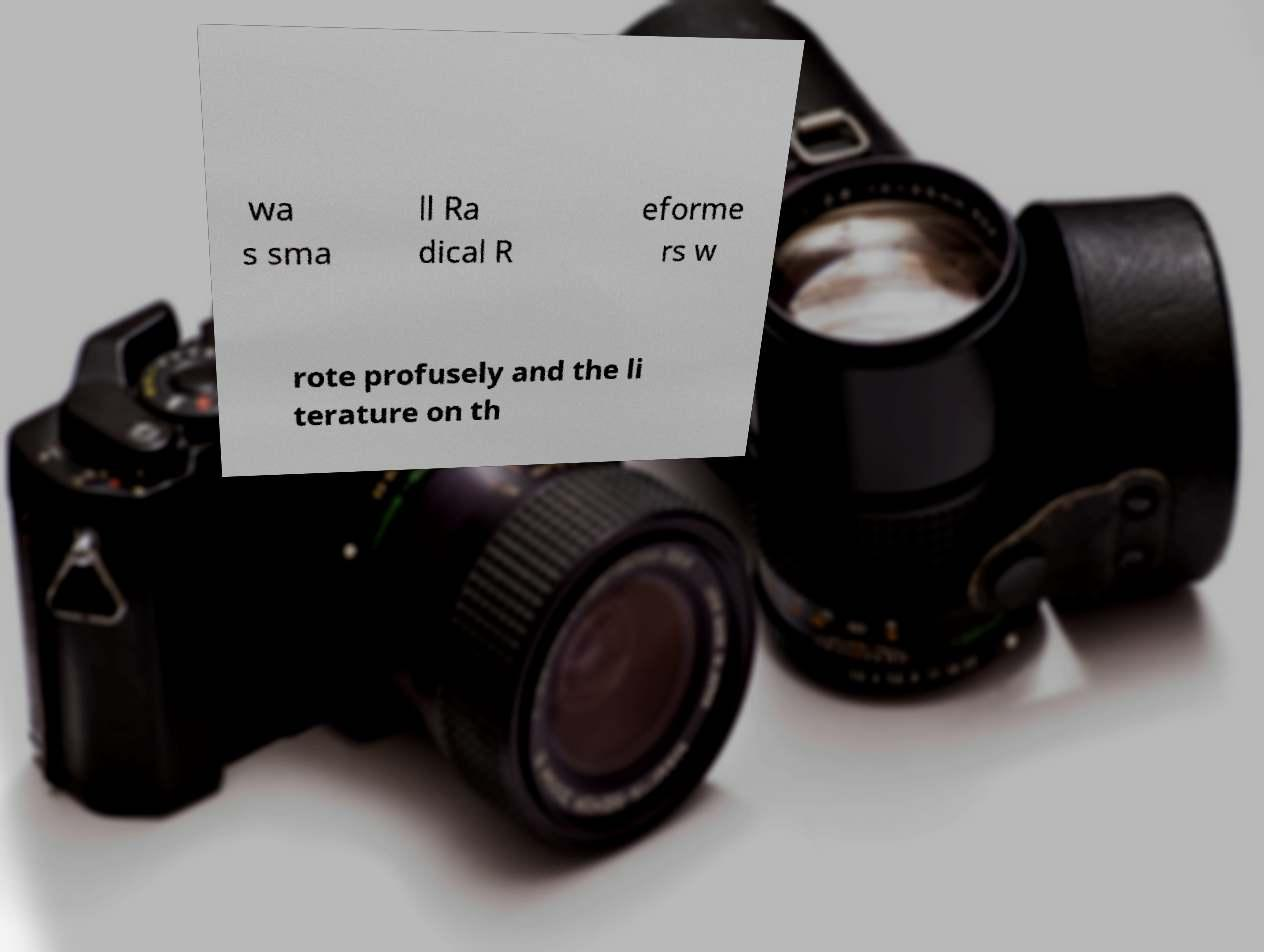Please read and relay the text visible in this image. What does it say? wa s sma ll Ra dical R eforme rs w rote profusely and the li terature on th 